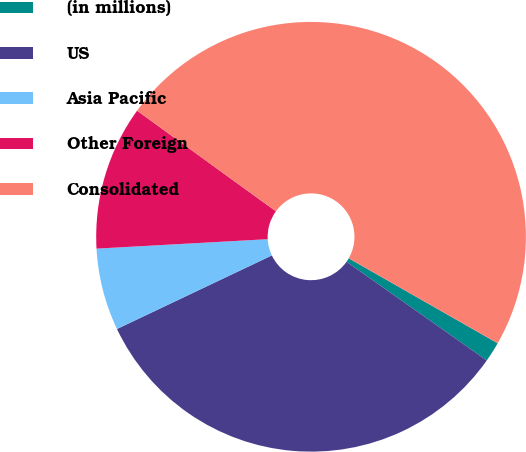<chart> <loc_0><loc_0><loc_500><loc_500><pie_chart><fcel>(in millions)<fcel>US<fcel>Asia Pacific<fcel>Other Foreign<fcel>Consolidated<nl><fcel>1.51%<fcel>33.18%<fcel>6.18%<fcel>10.86%<fcel>48.27%<nl></chart> 